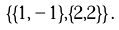Convert formula to latex. <formula><loc_0><loc_0><loc_500><loc_500>\{ \{ 1 , - 1 \} , \{ 2 , 2 \} \} \, .</formula> 